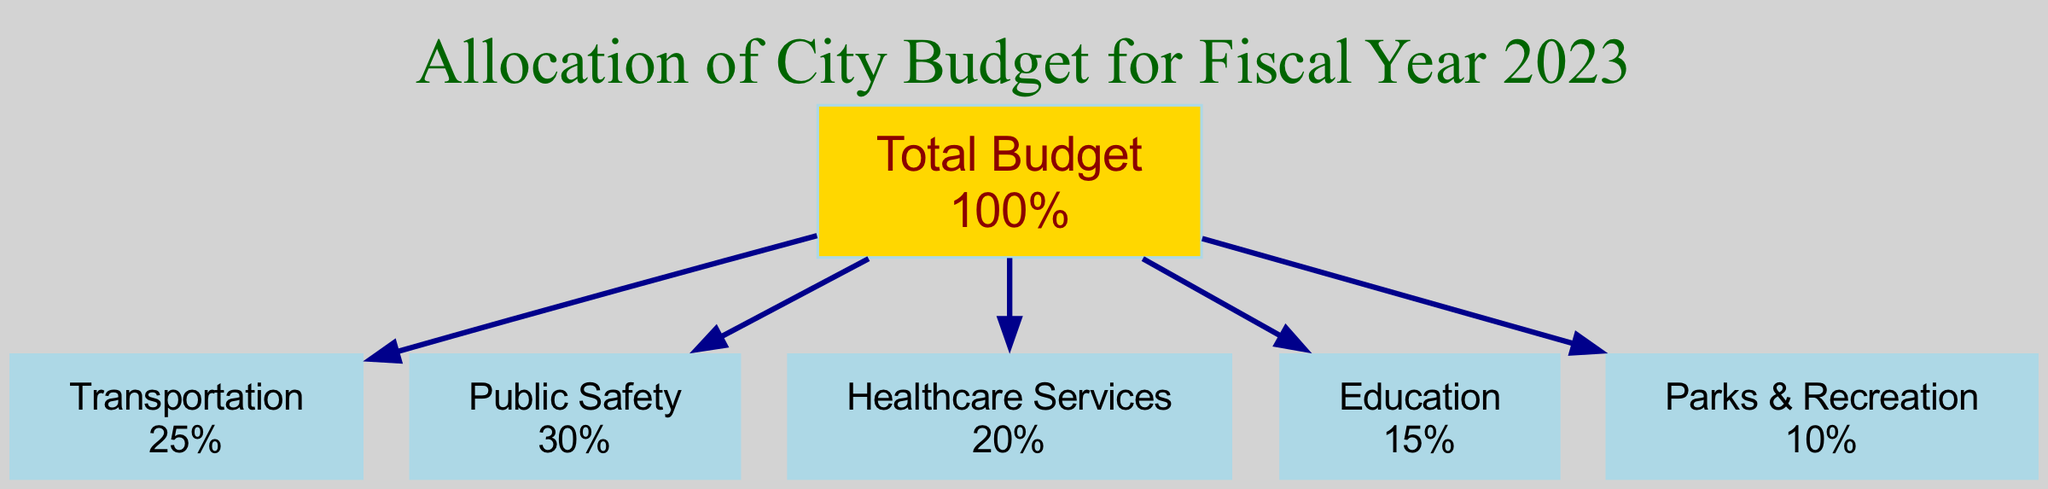What is the total percentage allocated to Public Safety? The diagram shows that Public Safety is a node and its percentage allocation is directly indicated next to it. Upon examining the Public Safety node, its percentage allocation reads "30%."
Answer: 30% How many sectors are included in the city budget allocation? The diagram lists six nodes, each representing a sector of the city budget. Counting these nodes gives the total number of sectors included. The nodes are: Transportation, Public Safety, Healthcare Services, Education, and Parks & Recreation, amounting to six sectors.
Answer: 6 What percentage is attributed to Parks & Recreation? Parks & Recreation is a specific node in the diagram, and its percentage allocation is stated along with its label. By checking the corresponding node, we find that it shows "10%."
Answer: 10% What is the percentage difference between Transportation and Healthcare Services? To find the percentage difference, we compare the allocation of the two nodes. Transportation is allocated "25%" and Healthcare Services "20%." Subtracting these values, we get 25% - 20% = 5%.
Answer: 5% If the total budget is $1,000,000, how much is allocated to Education? The diagram indicates the Education node has a percentage allocation of "15%." To find the amount allocated, we calculate 15% of $1,000,000. This is done by multiplying 1,000,000 * 0.15, which equals $150,000.
Answer: $150,000 Which sector has the highest budget allocation percentage? By reviewing the nodes and their corresponding percentages, we see that Public Safety has an allocation of "30%," which is the highest compared to the other sectors listed in the diagram.
Answer: Public Safety Which two sectors together make up more than half of the total budget? We examine the percentages of each sector. Public Safety (30%) plus Transportation (25%) equals 55%, which exceeds 50%. Therefore, these two sectors combined account for more than half of the total budget allocation.
Answer: Transportation and Public Safety What sector has the lowest budget allocation? Analyzing the percentage allocations of all sectors, we find that Parks & Recreation has the lowest percentage at "10%," making it the sector with the least funding.
Answer: Parks & Recreation 